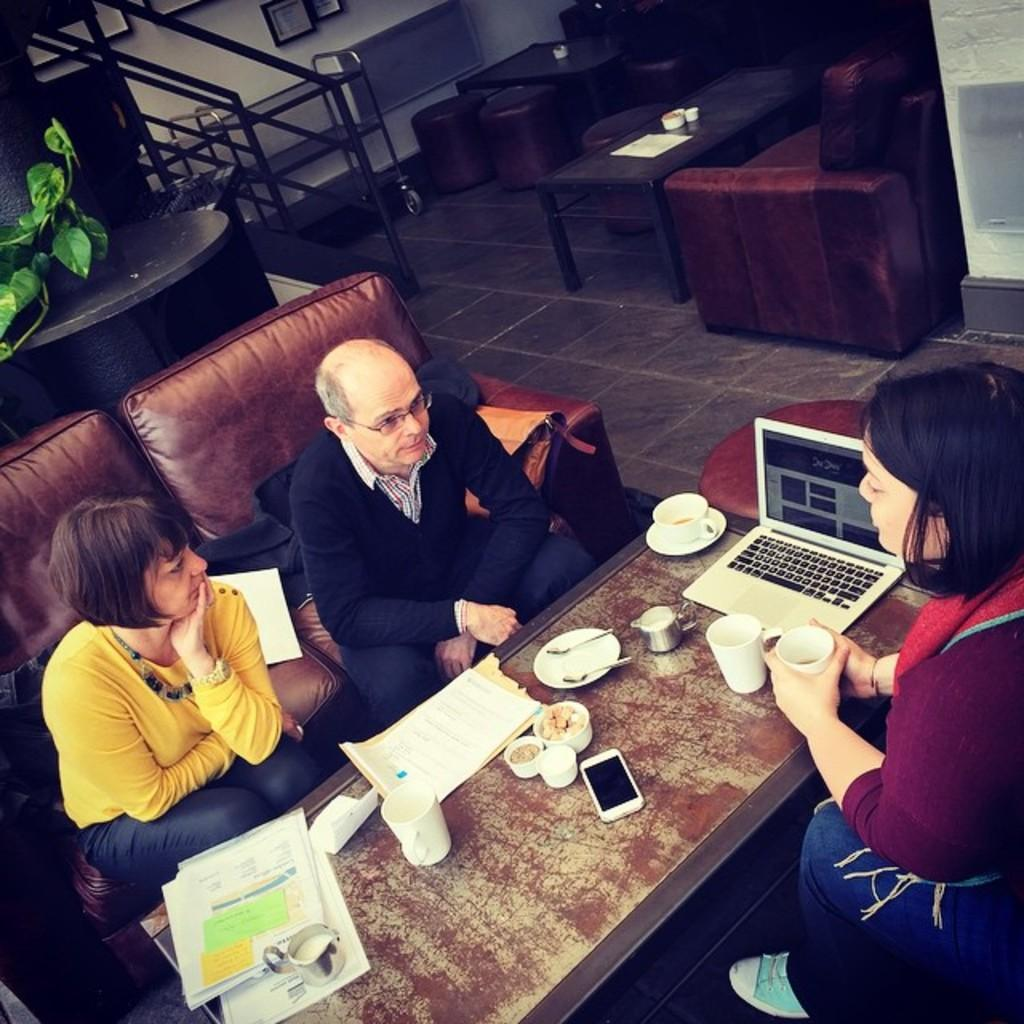How many people are sitting on the sofa in the image? There are 3 people sitting on the sofa in the image. What is in front of the sofa? There is a table in front of the sofa. What items can be seen on the table? Papers, glasses, a mobile phone, and a laptop are on the table. What is visible behind the sofa? Plants and stairs are visible behind the sofa. What type of shoes are visible on the table in the image? There are no shoes present on the table in the image. How does the taste of the oven compare to the taste of the laptop in the image? There is no oven or taste mentioned in the image; it features a table with papers, glasses, a mobile phone, and a laptop. 